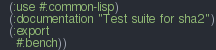Convert code to text. <code><loc_0><loc_0><loc_500><loc_500><_Lisp_>  (:use #:common-lisp)
  (:documentation "Test suite for sha2")
  (:export
    #:bench))

</code> 